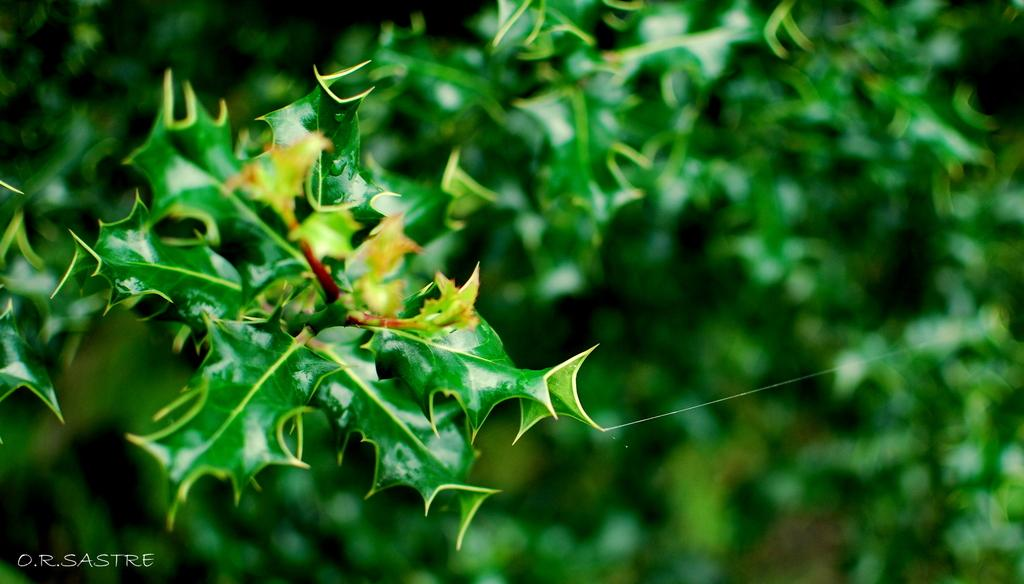What type of living organisms can be seen in the image? Plants can be seen in the image. How would you describe the background of the image? The background of the image is blurred and green. Where is the text located in the image? The text is in the bottom left side of the image. How many lizards can be seen basking in the sun in the image? There are no lizards present in the image. What type of coat is draped over the plants in the image? There is no coat present in the image; it only features plants and a blurred green background. 